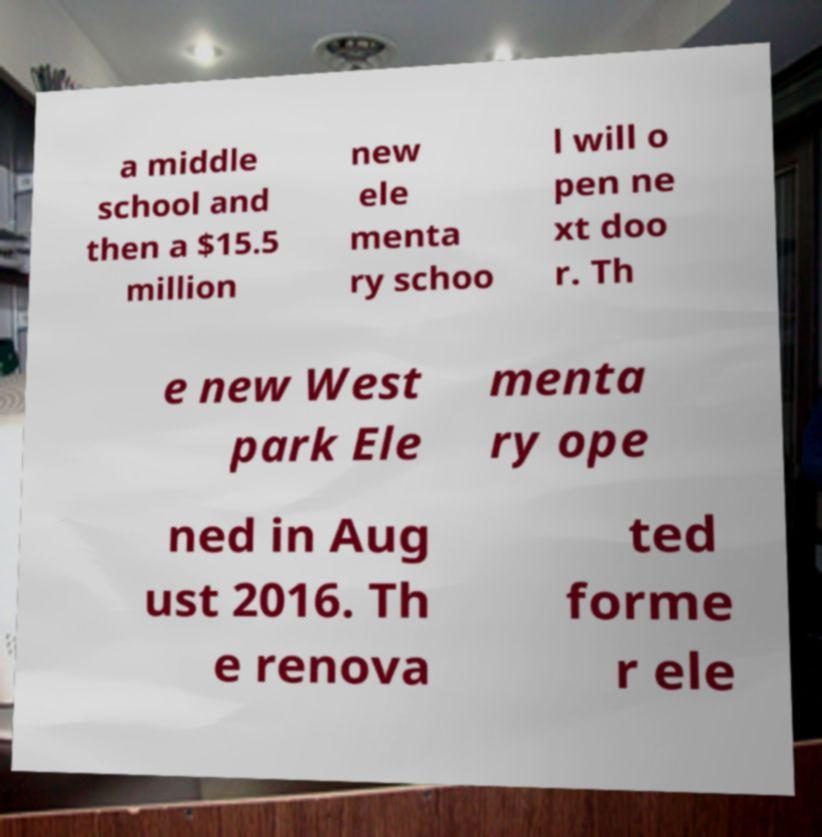Could you assist in decoding the text presented in this image and type it out clearly? a middle school and then a $15.5 million new ele menta ry schoo l will o pen ne xt doo r. Th e new West park Ele menta ry ope ned in Aug ust 2016. Th e renova ted forme r ele 